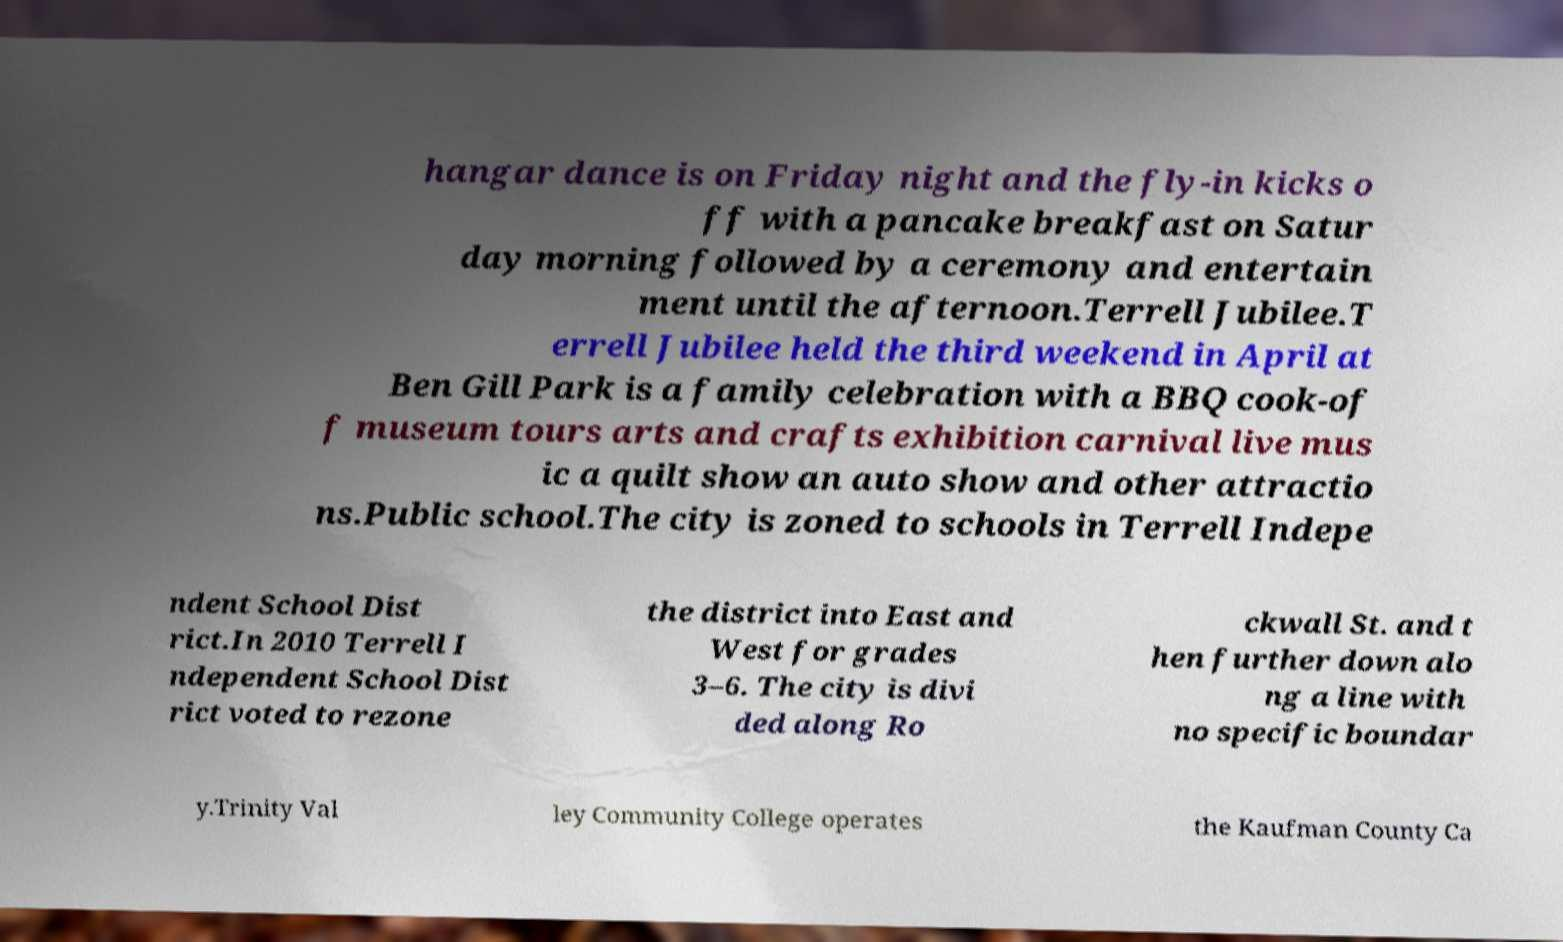Could you assist in decoding the text presented in this image and type it out clearly? hangar dance is on Friday night and the fly-in kicks o ff with a pancake breakfast on Satur day morning followed by a ceremony and entertain ment until the afternoon.Terrell Jubilee.T errell Jubilee held the third weekend in April at Ben Gill Park is a family celebration with a BBQ cook-of f museum tours arts and crafts exhibition carnival live mus ic a quilt show an auto show and other attractio ns.Public school.The city is zoned to schools in Terrell Indepe ndent School Dist rict.In 2010 Terrell I ndependent School Dist rict voted to rezone the district into East and West for grades 3–6. The city is divi ded along Ro ckwall St. and t hen further down alo ng a line with no specific boundar y.Trinity Val ley Community College operates the Kaufman County Ca 